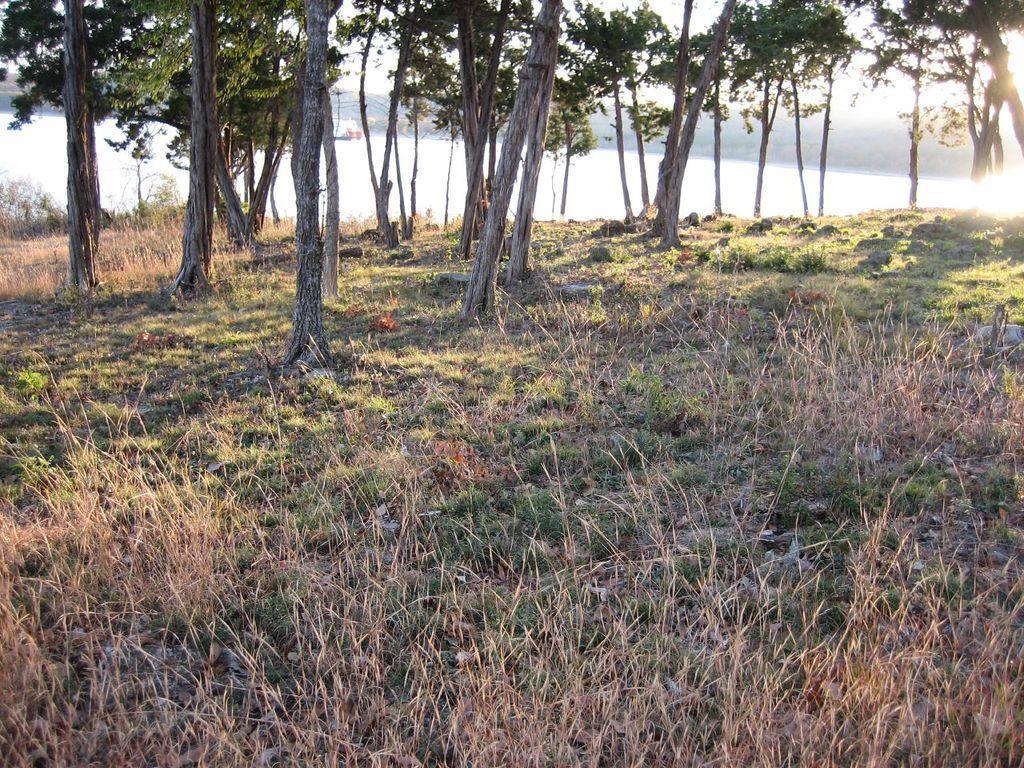Describe this image in one or two sentences. In the image we can see there is a ground which is covered with dry grass and there are lot of trees in the area. Behind there is a river. 